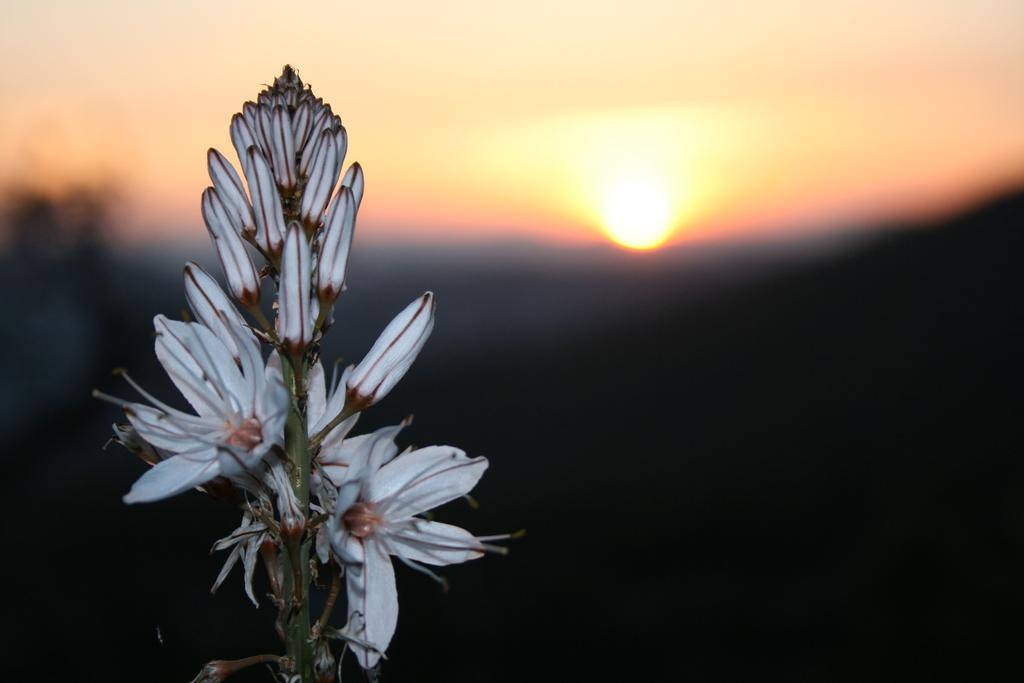Please provide a concise description of this image. In the front of the image there are flowers, buds and stem. In the background of the image it is blurry. 